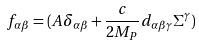Convert formula to latex. <formula><loc_0><loc_0><loc_500><loc_500>f _ { \alpha \beta } = ( A \delta _ { \alpha \beta } + \frac { c } { 2 M _ { P } } d _ { \alpha \beta \gamma } \Sigma ^ { \gamma } )</formula> 